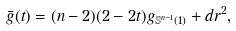Convert formula to latex. <formula><loc_0><loc_0><loc_500><loc_500>\bar { g } ( t ) = ( n - 2 ) ( 2 - 2 t ) g _ { \mathbb { S } ^ { n - 1 } ( 1 ) } + d r ^ { 2 } ,</formula> 